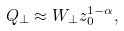Convert formula to latex. <formula><loc_0><loc_0><loc_500><loc_500>Q _ { \perp } \approx W _ { \perp } z _ { 0 } ^ { 1 - \alpha } ,</formula> 